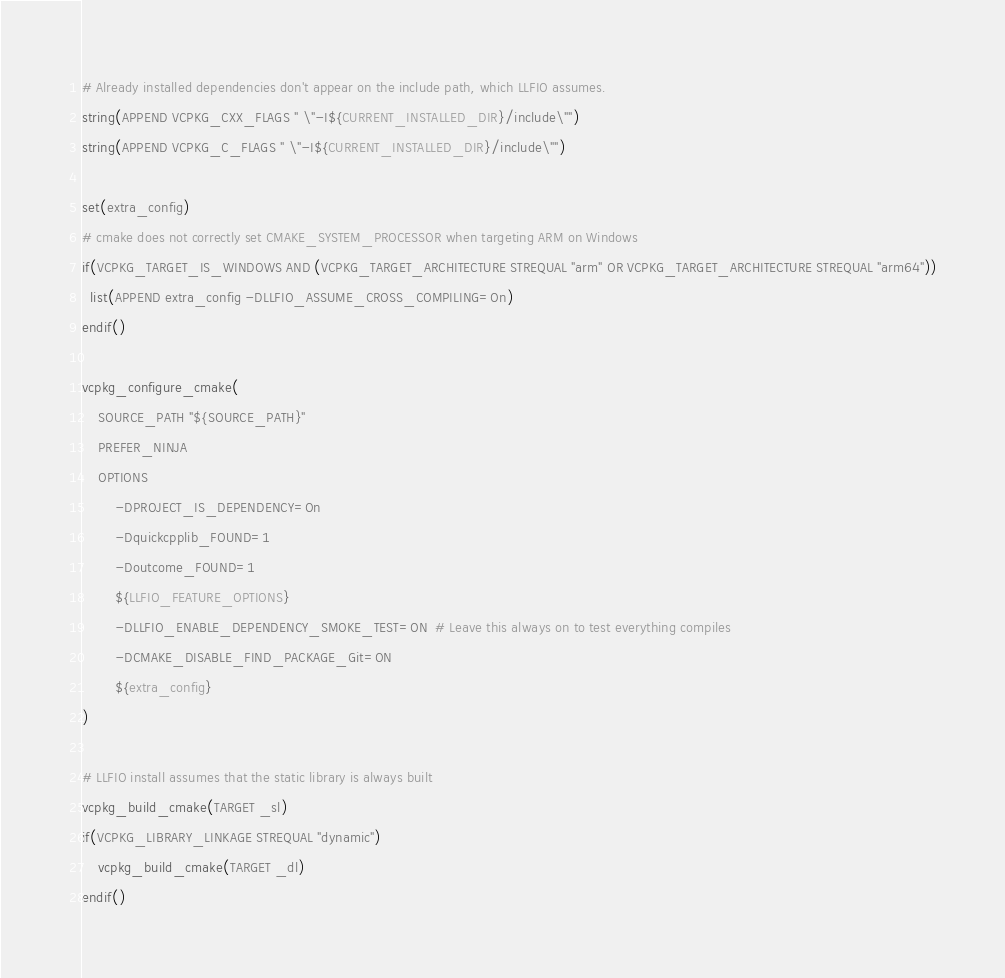Convert code to text. <code><loc_0><loc_0><loc_500><loc_500><_CMake_>
# Already installed dependencies don't appear on the include path, which LLFIO assumes.
string(APPEND VCPKG_CXX_FLAGS " \"-I${CURRENT_INSTALLED_DIR}/include\"")
string(APPEND VCPKG_C_FLAGS " \"-I${CURRENT_INSTALLED_DIR}/include\"")

set(extra_config)
# cmake does not correctly set CMAKE_SYSTEM_PROCESSOR when targeting ARM on Windows
if(VCPKG_TARGET_IS_WINDOWS AND (VCPKG_TARGET_ARCHITECTURE STREQUAL "arm" OR VCPKG_TARGET_ARCHITECTURE STREQUAL "arm64"))
  list(APPEND extra_config -DLLFIO_ASSUME_CROSS_COMPILING=On)
endif()

vcpkg_configure_cmake(
    SOURCE_PATH "${SOURCE_PATH}"
    PREFER_NINJA
    OPTIONS
        -DPROJECT_IS_DEPENDENCY=On
        -Dquickcpplib_FOUND=1
        -Doutcome_FOUND=1
        ${LLFIO_FEATURE_OPTIONS}
        -DLLFIO_ENABLE_DEPENDENCY_SMOKE_TEST=ON  # Leave this always on to test everything compiles
        -DCMAKE_DISABLE_FIND_PACKAGE_Git=ON
        ${extra_config}
)

# LLFIO install assumes that the static library is always built
vcpkg_build_cmake(TARGET _sl)
if(VCPKG_LIBRARY_LINKAGE STREQUAL "dynamic")
    vcpkg_build_cmake(TARGET _dl)
endif()
</code> 